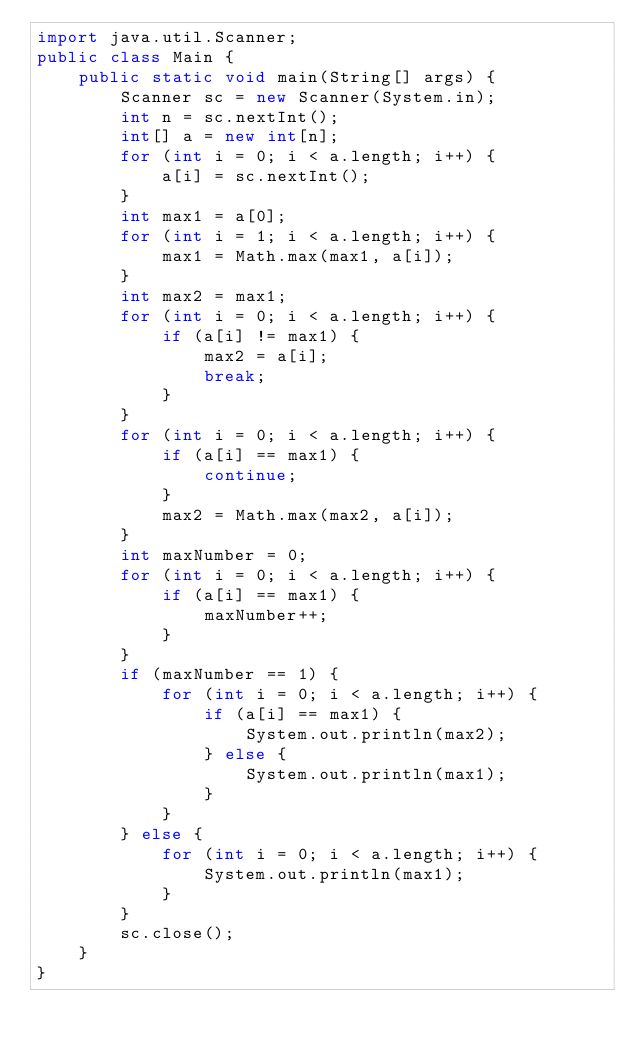<code> <loc_0><loc_0><loc_500><loc_500><_Java_>import java.util.Scanner;
public class Main {
    public static void main(String[] args) {
        Scanner sc = new Scanner(System.in);
        int n = sc.nextInt();
        int[] a = new int[n];
        for (int i = 0; i < a.length; i++) {
            a[i] = sc.nextInt();
        }
        int max1 = a[0];
        for (int i = 1; i < a.length; i++) {
            max1 = Math.max(max1, a[i]);
        }
        int max2 = max1;
        for (int i = 0; i < a.length; i++) {
            if (a[i] != max1) {
                max2 = a[i];
                break;
            }
        }
        for (int i = 0; i < a.length; i++) {
            if (a[i] == max1) {
                continue;
            }
            max2 = Math.max(max2, a[i]);
        }
        int maxNumber = 0;
        for (int i = 0; i < a.length; i++) {
            if (a[i] == max1) {
                maxNumber++;
            }
        }
        if (maxNumber == 1) {
            for (int i = 0; i < a.length; i++) {
                if (a[i] == max1) {
                    System.out.println(max2);
                } else {
                    System.out.println(max1);
                }
            }
        } else {
            for (int i = 0; i < a.length; i++) {
                System.out.println(max1);
            }
        }
        sc.close();
    }
}</code> 